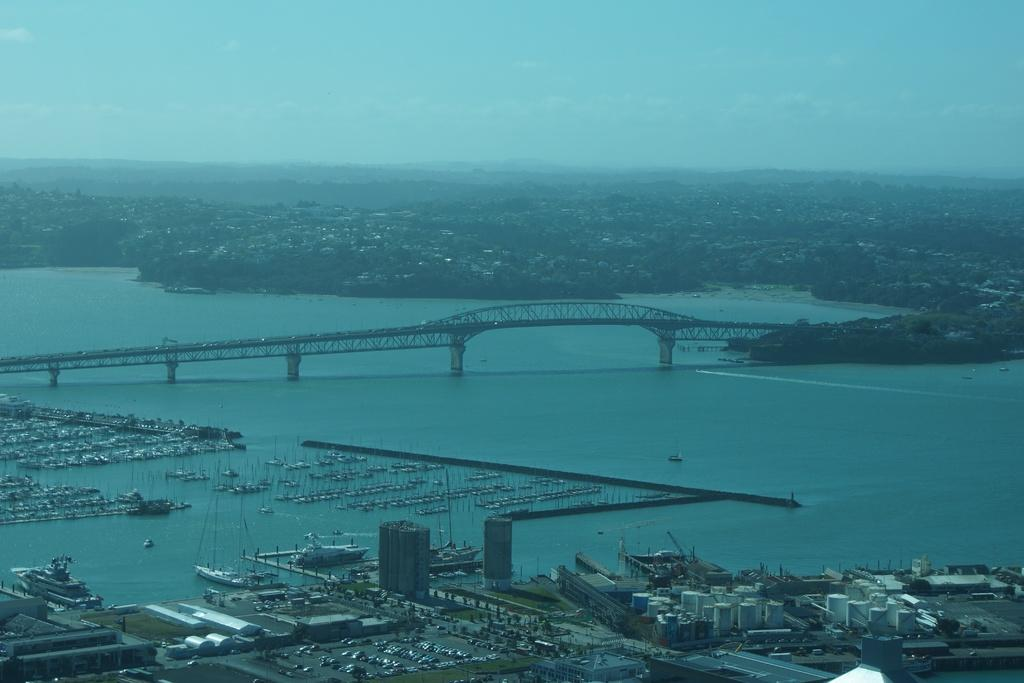What can be seen in the sky in the image? The sky with clouds is visible in the image. What type of structure is present in the image? There is a bridge in the image. What else can be seen in the image besides the bridge? There are buildings, trees, a river, ships, motor vehicles, poles, and roads visible in the image. What type of cabbage is being harvested in the image? There is no cabbage present in the image; it features a sky, clouds, bridge, buildings, trees, river, ships, motor vehicles, poles, and roads. 